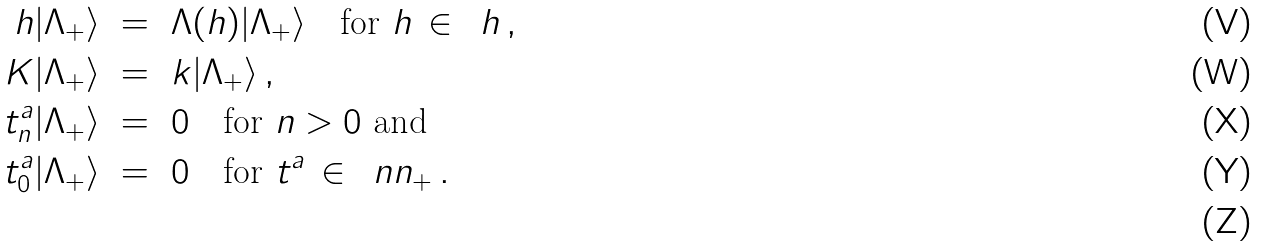<formula> <loc_0><loc_0><loc_500><loc_500>h | \Lambda _ { + } \rangle \ & = \ \Lambda ( h ) | \Lambda _ { + } \rangle \quad \text {for} \ h \, \in \, \ h \, , \\ K | \Lambda _ { + } \rangle \ & = \ k | \Lambda _ { + } \rangle \, , \\ t ^ { a } _ { n } | \Lambda _ { + } \rangle \ & = \ 0 \quad \text {for} \ n > 0 \ \text {and} \\ t ^ { a } _ { 0 } | \Lambda _ { + } \rangle \ & = \ 0 \quad \text {for} \ t ^ { a } \, \in \, \ n n _ { + } \, . \\</formula> 